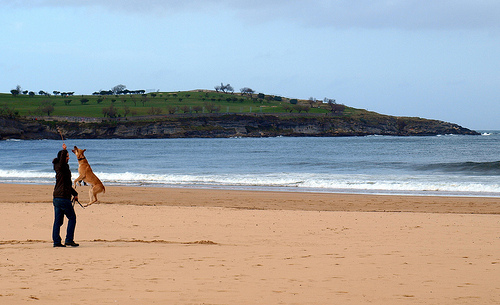Describe the setting of the image please. Of course! The setting is a tranquil beach scene. The shoreline meets a calm sea under a partly cloudy sky. In the background, there's a headland with visible greenery and what seem like a few structures or trees. The overall mood is serene, emphasizing leisure and the natural environment. 